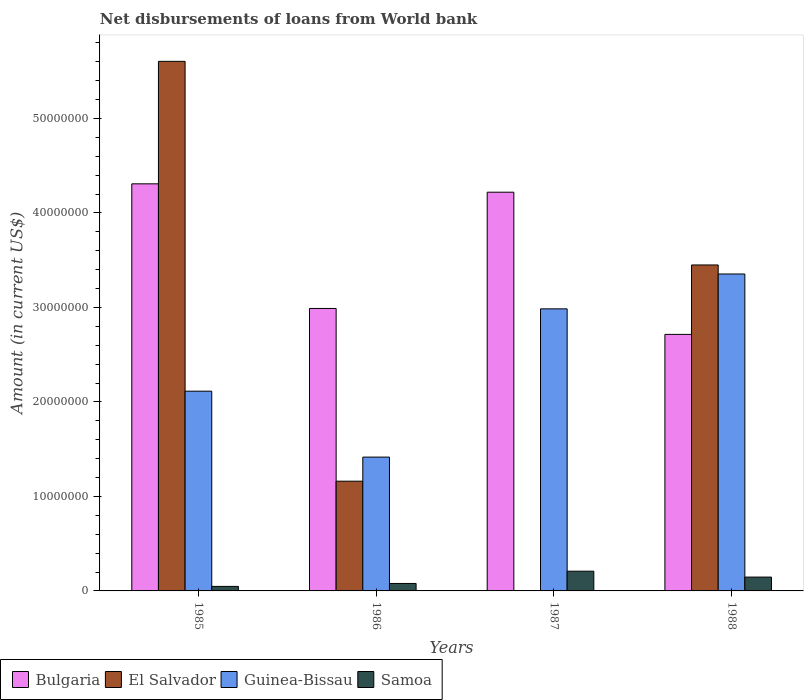In how many cases, is the number of bars for a given year not equal to the number of legend labels?
Your response must be concise. 1. What is the amount of loan disbursed from World Bank in Guinea-Bissau in 1987?
Your answer should be very brief. 2.99e+07. Across all years, what is the maximum amount of loan disbursed from World Bank in El Salvador?
Offer a very short reply. 5.60e+07. Across all years, what is the minimum amount of loan disbursed from World Bank in El Salvador?
Make the answer very short. 0. In which year was the amount of loan disbursed from World Bank in Bulgaria maximum?
Keep it short and to the point. 1985. What is the total amount of loan disbursed from World Bank in El Salvador in the graph?
Give a very brief answer. 1.02e+08. What is the difference between the amount of loan disbursed from World Bank in Bulgaria in 1985 and that in 1988?
Give a very brief answer. 1.59e+07. What is the difference between the amount of loan disbursed from World Bank in Bulgaria in 1987 and the amount of loan disbursed from World Bank in Guinea-Bissau in 1985?
Your response must be concise. 2.11e+07. What is the average amount of loan disbursed from World Bank in El Salvador per year?
Provide a succinct answer. 2.55e+07. In the year 1988, what is the difference between the amount of loan disbursed from World Bank in El Salvador and amount of loan disbursed from World Bank in Bulgaria?
Your response must be concise. 7.35e+06. In how many years, is the amount of loan disbursed from World Bank in Guinea-Bissau greater than 16000000 US$?
Provide a short and direct response. 3. What is the ratio of the amount of loan disbursed from World Bank in Samoa in 1985 to that in 1986?
Offer a terse response. 0.61. What is the difference between the highest and the second highest amount of loan disbursed from World Bank in Guinea-Bissau?
Your answer should be very brief. 3.69e+06. What is the difference between the highest and the lowest amount of loan disbursed from World Bank in Guinea-Bissau?
Offer a very short reply. 1.94e+07. Is it the case that in every year, the sum of the amount of loan disbursed from World Bank in Guinea-Bissau and amount of loan disbursed from World Bank in Bulgaria is greater than the sum of amount of loan disbursed from World Bank in El Salvador and amount of loan disbursed from World Bank in Samoa?
Keep it short and to the point. No. How many bars are there?
Ensure brevity in your answer.  15. Are all the bars in the graph horizontal?
Ensure brevity in your answer.  No. How many years are there in the graph?
Ensure brevity in your answer.  4. Are the values on the major ticks of Y-axis written in scientific E-notation?
Offer a very short reply. No. Does the graph contain any zero values?
Offer a terse response. Yes. Does the graph contain grids?
Give a very brief answer. No. Where does the legend appear in the graph?
Offer a terse response. Bottom left. How are the legend labels stacked?
Offer a terse response. Horizontal. What is the title of the graph?
Ensure brevity in your answer.  Net disbursements of loans from World bank. What is the Amount (in current US$) of Bulgaria in 1985?
Offer a terse response. 4.31e+07. What is the Amount (in current US$) in El Salvador in 1985?
Ensure brevity in your answer.  5.60e+07. What is the Amount (in current US$) in Guinea-Bissau in 1985?
Your answer should be very brief. 2.11e+07. What is the Amount (in current US$) in Samoa in 1985?
Make the answer very short. 4.78e+05. What is the Amount (in current US$) in Bulgaria in 1986?
Offer a terse response. 2.99e+07. What is the Amount (in current US$) in El Salvador in 1986?
Keep it short and to the point. 1.16e+07. What is the Amount (in current US$) of Guinea-Bissau in 1986?
Offer a terse response. 1.42e+07. What is the Amount (in current US$) in Samoa in 1986?
Offer a very short reply. 7.89e+05. What is the Amount (in current US$) of Bulgaria in 1987?
Provide a succinct answer. 4.22e+07. What is the Amount (in current US$) of El Salvador in 1987?
Give a very brief answer. 0. What is the Amount (in current US$) of Guinea-Bissau in 1987?
Ensure brevity in your answer.  2.99e+07. What is the Amount (in current US$) of Samoa in 1987?
Provide a succinct answer. 2.09e+06. What is the Amount (in current US$) of Bulgaria in 1988?
Provide a short and direct response. 2.71e+07. What is the Amount (in current US$) in El Salvador in 1988?
Offer a very short reply. 3.45e+07. What is the Amount (in current US$) in Guinea-Bissau in 1988?
Provide a succinct answer. 3.35e+07. What is the Amount (in current US$) of Samoa in 1988?
Your response must be concise. 1.46e+06. Across all years, what is the maximum Amount (in current US$) in Bulgaria?
Offer a terse response. 4.31e+07. Across all years, what is the maximum Amount (in current US$) in El Salvador?
Make the answer very short. 5.60e+07. Across all years, what is the maximum Amount (in current US$) in Guinea-Bissau?
Offer a terse response. 3.35e+07. Across all years, what is the maximum Amount (in current US$) in Samoa?
Your response must be concise. 2.09e+06. Across all years, what is the minimum Amount (in current US$) of Bulgaria?
Provide a short and direct response. 2.71e+07. Across all years, what is the minimum Amount (in current US$) of Guinea-Bissau?
Ensure brevity in your answer.  1.42e+07. Across all years, what is the minimum Amount (in current US$) in Samoa?
Make the answer very short. 4.78e+05. What is the total Amount (in current US$) in Bulgaria in the graph?
Offer a terse response. 1.42e+08. What is the total Amount (in current US$) of El Salvador in the graph?
Your answer should be very brief. 1.02e+08. What is the total Amount (in current US$) in Guinea-Bissau in the graph?
Provide a short and direct response. 9.87e+07. What is the total Amount (in current US$) of Samoa in the graph?
Make the answer very short. 4.82e+06. What is the difference between the Amount (in current US$) in Bulgaria in 1985 and that in 1986?
Provide a succinct answer. 1.32e+07. What is the difference between the Amount (in current US$) in El Salvador in 1985 and that in 1986?
Provide a short and direct response. 4.44e+07. What is the difference between the Amount (in current US$) of Guinea-Bissau in 1985 and that in 1986?
Keep it short and to the point. 6.98e+06. What is the difference between the Amount (in current US$) of Samoa in 1985 and that in 1986?
Keep it short and to the point. -3.11e+05. What is the difference between the Amount (in current US$) of Bulgaria in 1985 and that in 1987?
Offer a terse response. 8.85e+05. What is the difference between the Amount (in current US$) of Guinea-Bissau in 1985 and that in 1987?
Your answer should be very brief. -8.71e+06. What is the difference between the Amount (in current US$) in Samoa in 1985 and that in 1987?
Your answer should be compact. -1.61e+06. What is the difference between the Amount (in current US$) in Bulgaria in 1985 and that in 1988?
Your answer should be compact. 1.59e+07. What is the difference between the Amount (in current US$) in El Salvador in 1985 and that in 1988?
Your answer should be compact. 2.15e+07. What is the difference between the Amount (in current US$) in Guinea-Bissau in 1985 and that in 1988?
Provide a succinct answer. -1.24e+07. What is the difference between the Amount (in current US$) of Samoa in 1985 and that in 1988?
Your answer should be compact. -9.86e+05. What is the difference between the Amount (in current US$) of Bulgaria in 1986 and that in 1987?
Provide a short and direct response. -1.23e+07. What is the difference between the Amount (in current US$) in Guinea-Bissau in 1986 and that in 1987?
Ensure brevity in your answer.  -1.57e+07. What is the difference between the Amount (in current US$) in Samoa in 1986 and that in 1987?
Make the answer very short. -1.30e+06. What is the difference between the Amount (in current US$) of Bulgaria in 1986 and that in 1988?
Your answer should be very brief. 2.75e+06. What is the difference between the Amount (in current US$) in El Salvador in 1986 and that in 1988?
Offer a terse response. -2.29e+07. What is the difference between the Amount (in current US$) in Guinea-Bissau in 1986 and that in 1988?
Ensure brevity in your answer.  -1.94e+07. What is the difference between the Amount (in current US$) in Samoa in 1986 and that in 1988?
Provide a succinct answer. -6.75e+05. What is the difference between the Amount (in current US$) in Bulgaria in 1987 and that in 1988?
Your answer should be very brief. 1.51e+07. What is the difference between the Amount (in current US$) in Guinea-Bissau in 1987 and that in 1988?
Make the answer very short. -3.69e+06. What is the difference between the Amount (in current US$) of Samoa in 1987 and that in 1988?
Your answer should be compact. 6.24e+05. What is the difference between the Amount (in current US$) in Bulgaria in 1985 and the Amount (in current US$) in El Salvador in 1986?
Your answer should be very brief. 3.15e+07. What is the difference between the Amount (in current US$) in Bulgaria in 1985 and the Amount (in current US$) in Guinea-Bissau in 1986?
Offer a very short reply. 2.89e+07. What is the difference between the Amount (in current US$) of Bulgaria in 1985 and the Amount (in current US$) of Samoa in 1986?
Provide a succinct answer. 4.23e+07. What is the difference between the Amount (in current US$) in El Salvador in 1985 and the Amount (in current US$) in Guinea-Bissau in 1986?
Give a very brief answer. 4.19e+07. What is the difference between the Amount (in current US$) in El Salvador in 1985 and the Amount (in current US$) in Samoa in 1986?
Offer a terse response. 5.53e+07. What is the difference between the Amount (in current US$) in Guinea-Bissau in 1985 and the Amount (in current US$) in Samoa in 1986?
Make the answer very short. 2.04e+07. What is the difference between the Amount (in current US$) of Bulgaria in 1985 and the Amount (in current US$) of Guinea-Bissau in 1987?
Your answer should be very brief. 1.32e+07. What is the difference between the Amount (in current US$) in Bulgaria in 1985 and the Amount (in current US$) in Samoa in 1987?
Keep it short and to the point. 4.10e+07. What is the difference between the Amount (in current US$) of El Salvador in 1985 and the Amount (in current US$) of Guinea-Bissau in 1987?
Provide a succinct answer. 2.62e+07. What is the difference between the Amount (in current US$) of El Salvador in 1985 and the Amount (in current US$) of Samoa in 1987?
Ensure brevity in your answer.  5.40e+07. What is the difference between the Amount (in current US$) of Guinea-Bissau in 1985 and the Amount (in current US$) of Samoa in 1987?
Give a very brief answer. 1.91e+07. What is the difference between the Amount (in current US$) of Bulgaria in 1985 and the Amount (in current US$) of El Salvador in 1988?
Offer a very short reply. 8.59e+06. What is the difference between the Amount (in current US$) of Bulgaria in 1985 and the Amount (in current US$) of Guinea-Bissau in 1988?
Provide a succinct answer. 9.54e+06. What is the difference between the Amount (in current US$) of Bulgaria in 1985 and the Amount (in current US$) of Samoa in 1988?
Give a very brief answer. 4.16e+07. What is the difference between the Amount (in current US$) in El Salvador in 1985 and the Amount (in current US$) in Guinea-Bissau in 1988?
Your response must be concise. 2.25e+07. What is the difference between the Amount (in current US$) of El Salvador in 1985 and the Amount (in current US$) of Samoa in 1988?
Your answer should be very brief. 5.46e+07. What is the difference between the Amount (in current US$) of Guinea-Bissau in 1985 and the Amount (in current US$) of Samoa in 1988?
Offer a terse response. 1.97e+07. What is the difference between the Amount (in current US$) of Bulgaria in 1986 and the Amount (in current US$) of Guinea-Bissau in 1987?
Provide a succinct answer. 4.20e+04. What is the difference between the Amount (in current US$) in Bulgaria in 1986 and the Amount (in current US$) in Samoa in 1987?
Your answer should be compact. 2.78e+07. What is the difference between the Amount (in current US$) in El Salvador in 1986 and the Amount (in current US$) in Guinea-Bissau in 1987?
Ensure brevity in your answer.  -1.82e+07. What is the difference between the Amount (in current US$) in El Salvador in 1986 and the Amount (in current US$) in Samoa in 1987?
Provide a succinct answer. 9.52e+06. What is the difference between the Amount (in current US$) of Guinea-Bissau in 1986 and the Amount (in current US$) of Samoa in 1987?
Keep it short and to the point. 1.21e+07. What is the difference between the Amount (in current US$) in Bulgaria in 1986 and the Amount (in current US$) in El Salvador in 1988?
Keep it short and to the point. -4.60e+06. What is the difference between the Amount (in current US$) of Bulgaria in 1986 and the Amount (in current US$) of Guinea-Bissau in 1988?
Make the answer very short. -3.65e+06. What is the difference between the Amount (in current US$) in Bulgaria in 1986 and the Amount (in current US$) in Samoa in 1988?
Give a very brief answer. 2.84e+07. What is the difference between the Amount (in current US$) in El Salvador in 1986 and the Amount (in current US$) in Guinea-Bissau in 1988?
Offer a terse response. -2.19e+07. What is the difference between the Amount (in current US$) of El Salvador in 1986 and the Amount (in current US$) of Samoa in 1988?
Provide a short and direct response. 1.01e+07. What is the difference between the Amount (in current US$) of Guinea-Bissau in 1986 and the Amount (in current US$) of Samoa in 1988?
Your response must be concise. 1.27e+07. What is the difference between the Amount (in current US$) in Bulgaria in 1987 and the Amount (in current US$) in El Salvador in 1988?
Offer a very short reply. 7.70e+06. What is the difference between the Amount (in current US$) in Bulgaria in 1987 and the Amount (in current US$) in Guinea-Bissau in 1988?
Give a very brief answer. 8.66e+06. What is the difference between the Amount (in current US$) of Bulgaria in 1987 and the Amount (in current US$) of Samoa in 1988?
Give a very brief answer. 4.07e+07. What is the difference between the Amount (in current US$) of Guinea-Bissau in 1987 and the Amount (in current US$) of Samoa in 1988?
Provide a succinct answer. 2.84e+07. What is the average Amount (in current US$) in Bulgaria per year?
Provide a succinct answer. 3.56e+07. What is the average Amount (in current US$) of El Salvador per year?
Ensure brevity in your answer.  2.55e+07. What is the average Amount (in current US$) in Guinea-Bissau per year?
Provide a succinct answer. 2.47e+07. What is the average Amount (in current US$) of Samoa per year?
Keep it short and to the point. 1.20e+06. In the year 1985, what is the difference between the Amount (in current US$) in Bulgaria and Amount (in current US$) in El Salvador?
Provide a short and direct response. -1.30e+07. In the year 1985, what is the difference between the Amount (in current US$) in Bulgaria and Amount (in current US$) in Guinea-Bissau?
Your answer should be very brief. 2.19e+07. In the year 1985, what is the difference between the Amount (in current US$) in Bulgaria and Amount (in current US$) in Samoa?
Provide a succinct answer. 4.26e+07. In the year 1985, what is the difference between the Amount (in current US$) of El Salvador and Amount (in current US$) of Guinea-Bissau?
Your response must be concise. 3.49e+07. In the year 1985, what is the difference between the Amount (in current US$) in El Salvador and Amount (in current US$) in Samoa?
Give a very brief answer. 5.56e+07. In the year 1985, what is the difference between the Amount (in current US$) in Guinea-Bissau and Amount (in current US$) in Samoa?
Your response must be concise. 2.07e+07. In the year 1986, what is the difference between the Amount (in current US$) of Bulgaria and Amount (in current US$) of El Salvador?
Your answer should be compact. 1.83e+07. In the year 1986, what is the difference between the Amount (in current US$) of Bulgaria and Amount (in current US$) of Guinea-Bissau?
Provide a succinct answer. 1.57e+07. In the year 1986, what is the difference between the Amount (in current US$) of Bulgaria and Amount (in current US$) of Samoa?
Offer a very short reply. 2.91e+07. In the year 1986, what is the difference between the Amount (in current US$) in El Salvador and Amount (in current US$) in Guinea-Bissau?
Your answer should be compact. -2.55e+06. In the year 1986, what is the difference between the Amount (in current US$) in El Salvador and Amount (in current US$) in Samoa?
Provide a short and direct response. 1.08e+07. In the year 1986, what is the difference between the Amount (in current US$) in Guinea-Bissau and Amount (in current US$) in Samoa?
Provide a succinct answer. 1.34e+07. In the year 1987, what is the difference between the Amount (in current US$) of Bulgaria and Amount (in current US$) of Guinea-Bissau?
Ensure brevity in your answer.  1.23e+07. In the year 1987, what is the difference between the Amount (in current US$) of Bulgaria and Amount (in current US$) of Samoa?
Offer a terse response. 4.01e+07. In the year 1987, what is the difference between the Amount (in current US$) of Guinea-Bissau and Amount (in current US$) of Samoa?
Give a very brief answer. 2.78e+07. In the year 1988, what is the difference between the Amount (in current US$) in Bulgaria and Amount (in current US$) in El Salvador?
Offer a terse response. -7.35e+06. In the year 1988, what is the difference between the Amount (in current US$) in Bulgaria and Amount (in current US$) in Guinea-Bissau?
Provide a short and direct response. -6.39e+06. In the year 1988, what is the difference between the Amount (in current US$) in Bulgaria and Amount (in current US$) in Samoa?
Give a very brief answer. 2.57e+07. In the year 1988, what is the difference between the Amount (in current US$) of El Salvador and Amount (in current US$) of Guinea-Bissau?
Your response must be concise. 9.56e+05. In the year 1988, what is the difference between the Amount (in current US$) in El Salvador and Amount (in current US$) in Samoa?
Make the answer very short. 3.30e+07. In the year 1988, what is the difference between the Amount (in current US$) of Guinea-Bissau and Amount (in current US$) of Samoa?
Your answer should be very brief. 3.21e+07. What is the ratio of the Amount (in current US$) of Bulgaria in 1985 to that in 1986?
Offer a very short reply. 1.44. What is the ratio of the Amount (in current US$) of El Salvador in 1985 to that in 1986?
Your response must be concise. 4.83. What is the ratio of the Amount (in current US$) in Guinea-Bissau in 1985 to that in 1986?
Your answer should be compact. 1.49. What is the ratio of the Amount (in current US$) in Samoa in 1985 to that in 1986?
Keep it short and to the point. 0.61. What is the ratio of the Amount (in current US$) in Guinea-Bissau in 1985 to that in 1987?
Give a very brief answer. 0.71. What is the ratio of the Amount (in current US$) in Samoa in 1985 to that in 1987?
Make the answer very short. 0.23. What is the ratio of the Amount (in current US$) of Bulgaria in 1985 to that in 1988?
Your answer should be very brief. 1.59. What is the ratio of the Amount (in current US$) in El Salvador in 1985 to that in 1988?
Keep it short and to the point. 1.62. What is the ratio of the Amount (in current US$) in Guinea-Bissau in 1985 to that in 1988?
Ensure brevity in your answer.  0.63. What is the ratio of the Amount (in current US$) in Samoa in 1985 to that in 1988?
Your answer should be very brief. 0.33. What is the ratio of the Amount (in current US$) in Bulgaria in 1986 to that in 1987?
Offer a terse response. 0.71. What is the ratio of the Amount (in current US$) of Guinea-Bissau in 1986 to that in 1987?
Keep it short and to the point. 0.47. What is the ratio of the Amount (in current US$) of Samoa in 1986 to that in 1987?
Provide a succinct answer. 0.38. What is the ratio of the Amount (in current US$) in Bulgaria in 1986 to that in 1988?
Your answer should be compact. 1.1. What is the ratio of the Amount (in current US$) in El Salvador in 1986 to that in 1988?
Your response must be concise. 0.34. What is the ratio of the Amount (in current US$) of Guinea-Bissau in 1986 to that in 1988?
Offer a very short reply. 0.42. What is the ratio of the Amount (in current US$) in Samoa in 1986 to that in 1988?
Make the answer very short. 0.54. What is the ratio of the Amount (in current US$) of Bulgaria in 1987 to that in 1988?
Your answer should be compact. 1.55. What is the ratio of the Amount (in current US$) of Guinea-Bissau in 1987 to that in 1988?
Your answer should be very brief. 0.89. What is the ratio of the Amount (in current US$) of Samoa in 1987 to that in 1988?
Your answer should be compact. 1.43. What is the difference between the highest and the second highest Amount (in current US$) in Bulgaria?
Your answer should be very brief. 8.85e+05. What is the difference between the highest and the second highest Amount (in current US$) of El Salvador?
Offer a terse response. 2.15e+07. What is the difference between the highest and the second highest Amount (in current US$) of Guinea-Bissau?
Your answer should be very brief. 3.69e+06. What is the difference between the highest and the second highest Amount (in current US$) of Samoa?
Your answer should be very brief. 6.24e+05. What is the difference between the highest and the lowest Amount (in current US$) of Bulgaria?
Your response must be concise. 1.59e+07. What is the difference between the highest and the lowest Amount (in current US$) in El Salvador?
Provide a short and direct response. 5.60e+07. What is the difference between the highest and the lowest Amount (in current US$) of Guinea-Bissau?
Offer a very short reply. 1.94e+07. What is the difference between the highest and the lowest Amount (in current US$) in Samoa?
Give a very brief answer. 1.61e+06. 